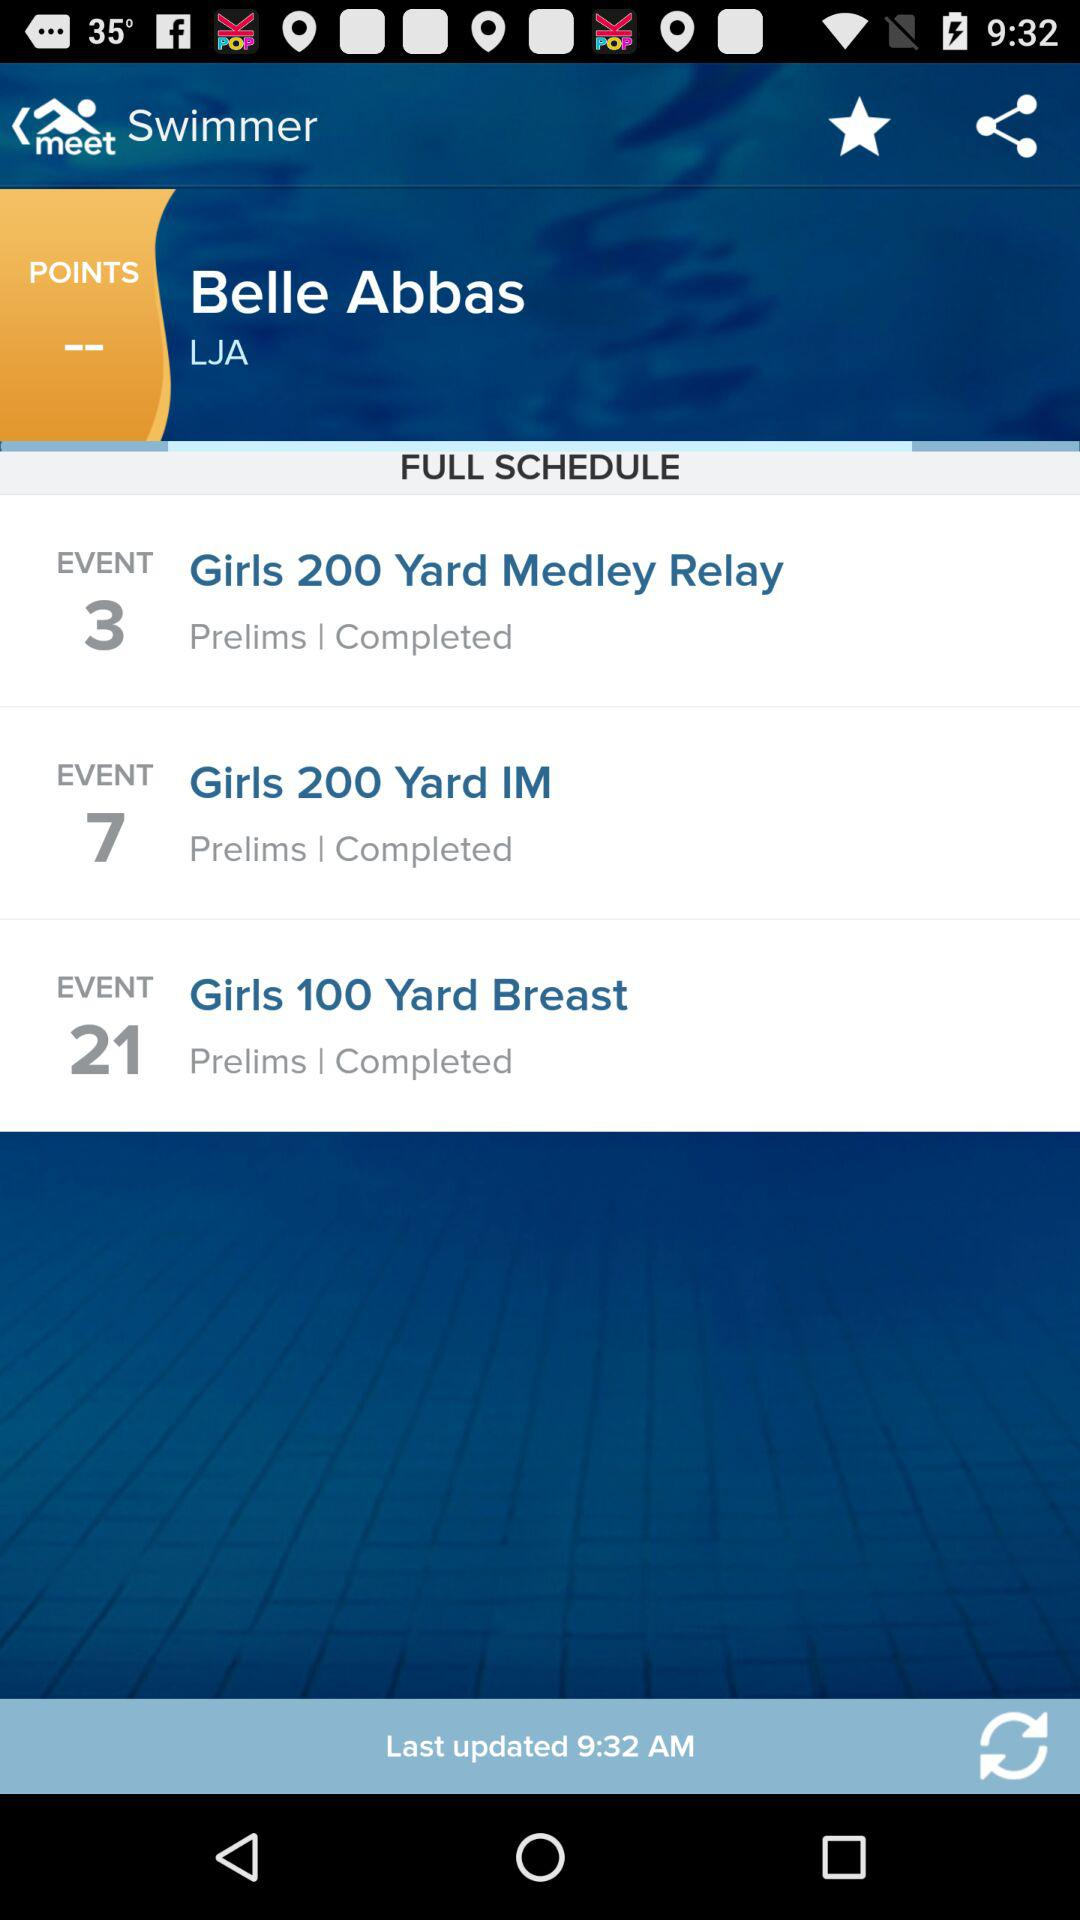How many events did Belle Abbas compete in?
Answer the question using a single word or phrase. 3 